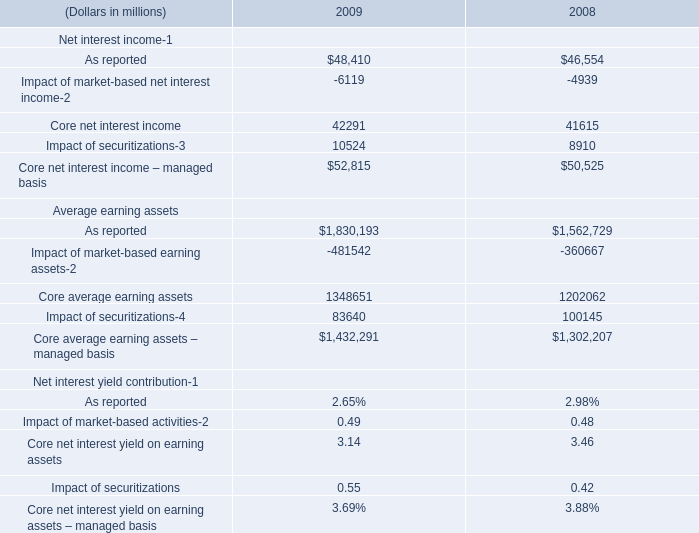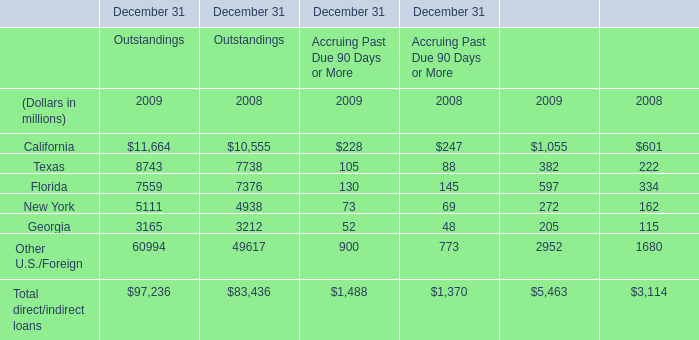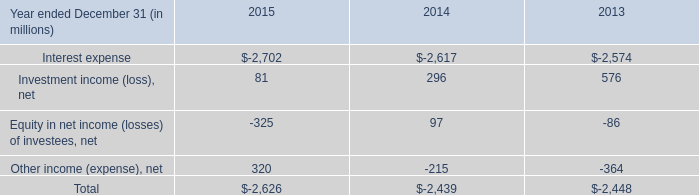what's the total amount of Texas of December 31 Outstandings 2009, and Interest expense of 2013 ? 
Computations: (8743.0 + 2574.0)
Answer: 11317.0. 